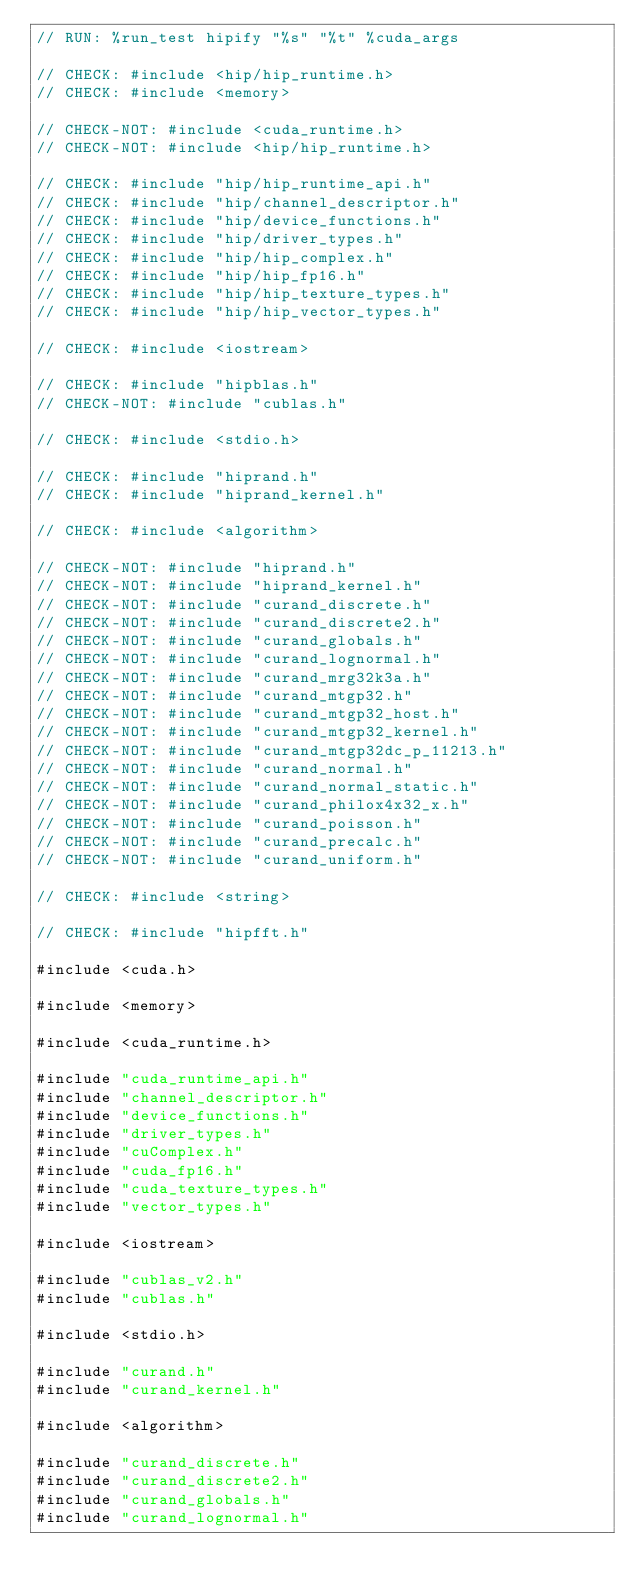Convert code to text. <code><loc_0><loc_0><loc_500><loc_500><_Cuda_>// RUN: %run_test hipify "%s" "%t" %cuda_args

// CHECK: #include <hip/hip_runtime.h>
// CHECK: #include <memory>

// CHECK-NOT: #include <cuda_runtime.h>
// CHECK-NOT: #include <hip/hip_runtime.h>

// CHECK: #include "hip/hip_runtime_api.h"
// CHECK: #include "hip/channel_descriptor.h"
// CHECK: #include "hip/device_functions.h"
// CHECK: #include "hip/driver_types.h"
// CHECK: #include "hip/hip_complex.h"
// CHECK: #include "hip/hip_fp16.h"
// CHECK: #include "hip/hip_texture_types.h"
// CHECK: #include "hip/hip_vector_types.h"

// CHECK: #include <iostream>

// CHECK: #include "hipblas.h"
// CHECK-NOT: #include "cublas.h"

// CHECK: #include <stdio.h>

// CHECK: #include "hiprand.h"
// CHECK: #include "hiprand_kernel.h"

// CHECK: #include <algorithm>

// CHECK-NOT: #include "hiprand.h"
// CHECK-NOT: #include "hiprand_kernel.h"
// CHECK-NOT: #include "curand_discrete.h"
// CHECK-NOT: #include "curand_discrete2.h"
// CHECK-NOT: #include "curand_globals.h"
// CHECK-NOT: #include "curand_lognormal.h"
// CHECK-NOT: #include "curand_mrg32k3a.h"
// CHECK-NOT: #include "curand_mtgp32.h"
// CHECK-NOT: #include "curand_mtgp32_host.h"
// CHECK-NOT: #include "curand_mtgp32_kernel.h"
// CHECK-NOT: #include "curand_mtgp32dc_p_11213.h"
// CHECK-NOT: #include "curand_normal.h"
// CHECK-NOT: #include "curand_normal_static.h"
// CHECK-NOT: #include "curand_philox4x32_x.h"
// CHECK-NOT: #include "curand_poisson.h"
// CHECK-NOT: #include "curand_precalc.h"
// CHECK-NOT: #include "curand_uniform.h"

// CHECK: #include <string>

// CHECK: #include "hipfft.h"

#include <cuda.h>

#include <memory>

#include <cuda_runtime.h>

#include "cuda_runtime_api.h"
#include "channel_descriptor.h"
#include "device_functions.h"
#include "driver_types.h"
#include "cuComplex.h"
#include "cuda_fp16.h"
#include "cuda_texture_types.h"
#include "vector_types.h"

#include <iostream>

#include "cublas_v2.h"
#include "cublas.h"

#include <stdio.h>

#include "curand.h"
#include "curand_kernel.h"

#include <algorithm>

#include "curand_discrete.h"
#include "curand_discrete2.h"
#include "curand_globals.h"
#include "curand_lognormal.h"</code> 